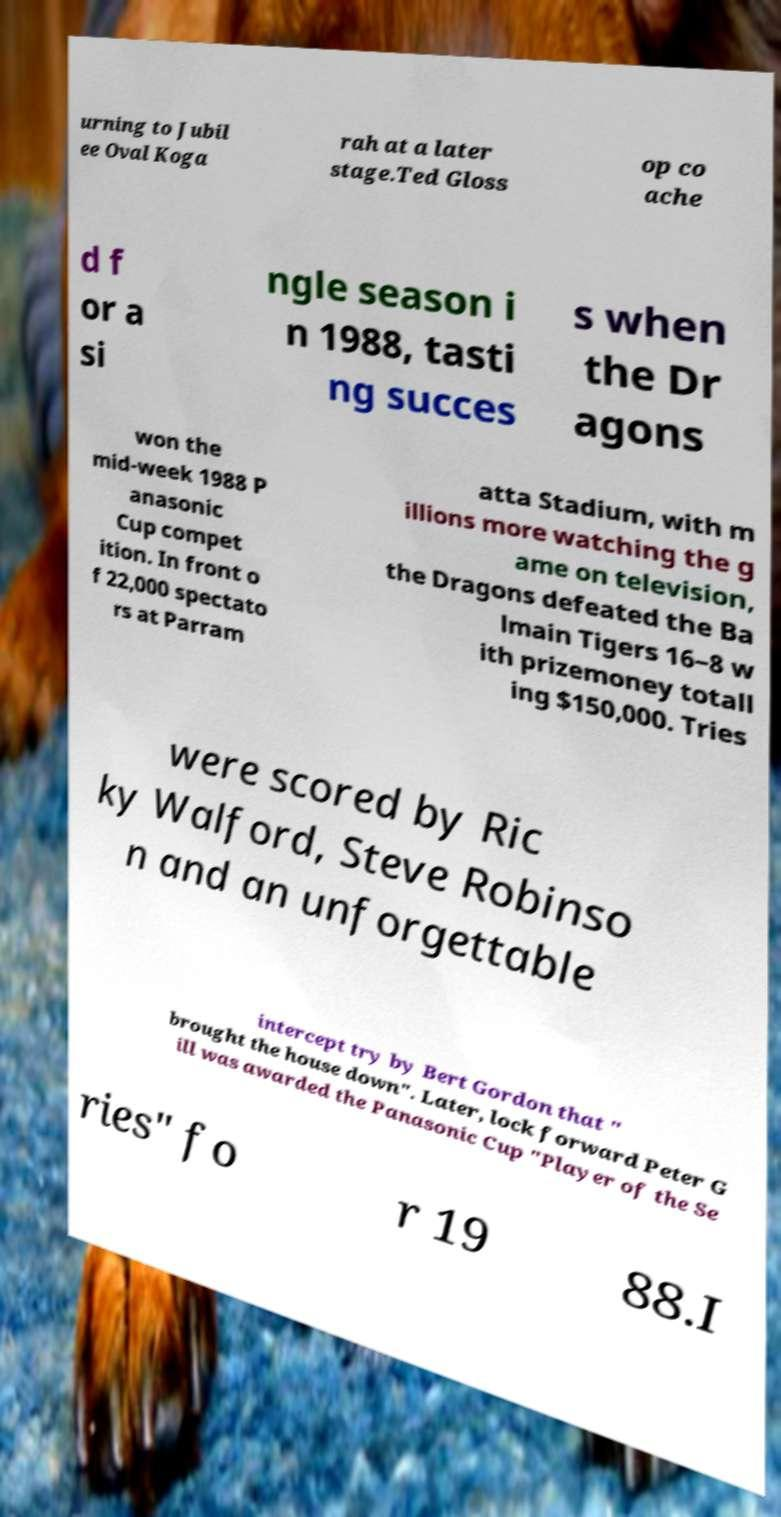For documentation purposes, I need the text within this image transcribed. Could you provide that? urning to Jubil ee Oval Koga rah at a later stage.Ted Gloss op co ache d f or a si ngle season i n 1988, tasti ng succes s when the Dr agons won the mid-week 1988 P anasonic Cup compet ition. In front o f 22,000 spectato rs at Parram atta Stadium, with m illions more watching the g ame on television, the Dragons defeated the Ba lmain Tigers 16–8 w ith prizemoney totall ing $150,000. Tries were scored by Ric ky Walford, Steve Robinso n and an unforgettable intercept try by Bert Gordon that " brought the house down". Later, lock forward Peter G ill was awarded the Panasonic Cup "Player of the Se ries" fo r 19 88.I 